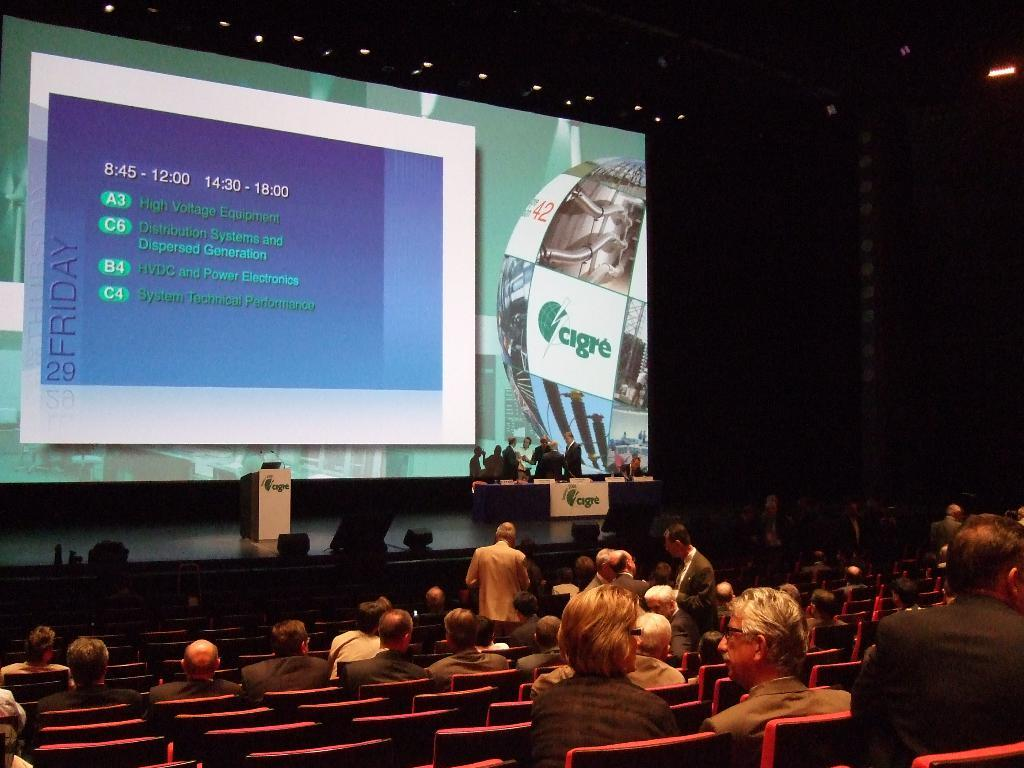<image>
Provide a brief description of the given image. A conference room with people seated looking at a large screen with electric power bullet points. 